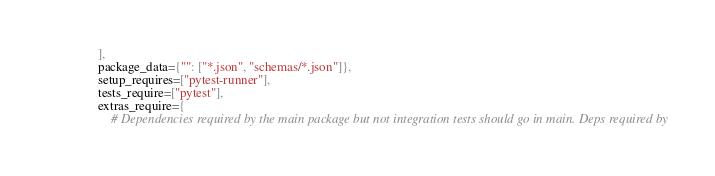Convert code to text. <code><loc_0><loc_0><loc_500><loc_500><_Python_>    ],
    package_data={"": ["*.json", "schemas/*.json"]},
    setup_requires=["pytest-runner"],
    tests_require=["pytest"],
    extras_require={
        # Dependencies required by the main package but not integration tests should go in main. Deps required by</code> 